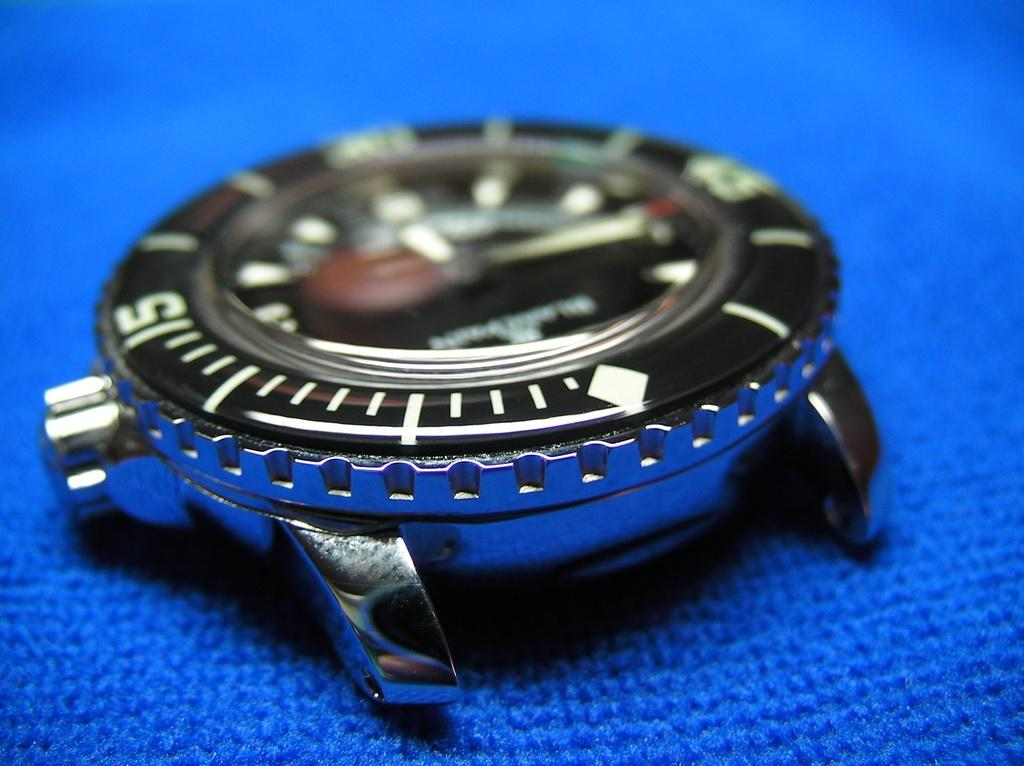<image>
Relay a brief, clear account of the picture shown. Face of a watch with the number 15 on the left. 